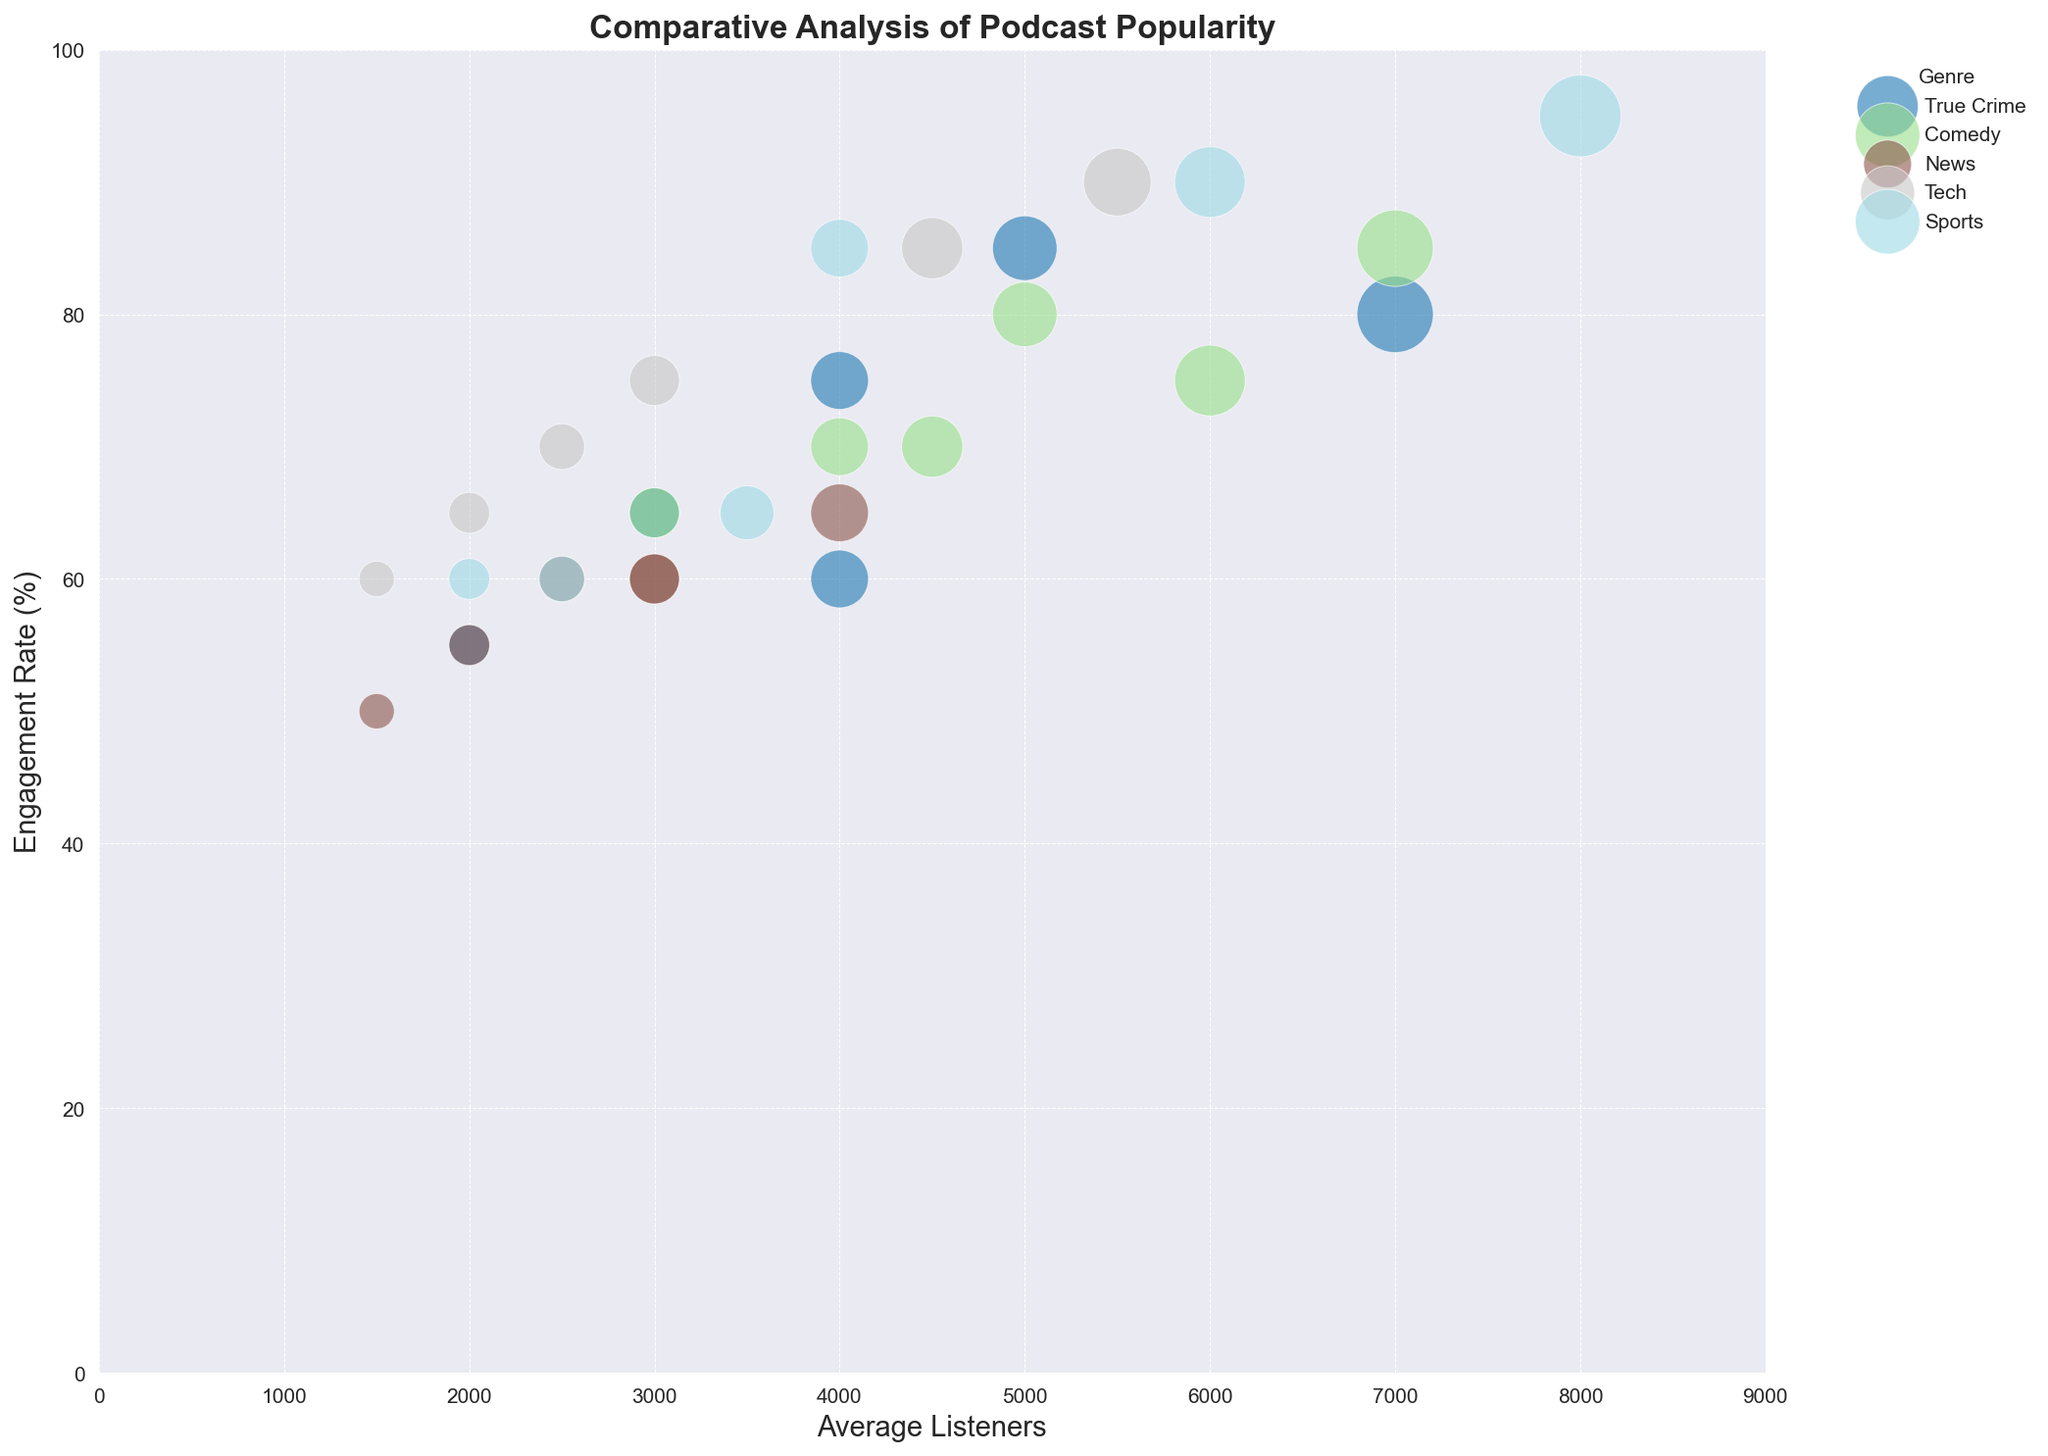What genre has the highest overall engagement rate and which age and gender group does it represent? To find the highest overall engagement rate, we need to look at the bubbles with the highest position on the y-axis (Engagement Rate). The highest bubble corresponds to the Sports genre for the 25-34 male listener group. This is indicated by the label and the highest position on the y-axis.
Answer: Sports, 25-34, Male What's the average engagement rate for True Crime podcasts across all demographic segments? To calculate the average engagement rate for True Crime, we sum the engagement rates of all True Crime segments and divide by the number of segments. The engagement rates are 85, 80, 75, 65, 60, and 55. So, (85+80+75+65+60+55)/6 = 70.
Answer: 70 Which genre has the most balanced average listener between males and females aged 25-34? To determine this, compare the average listeners for males and females in the 25-34 age group for each genre. For True Crime: Female 7000, Male 4000; Comedy: Female 6000, Male 7000; News: Female 4000, Male 3000; Tech: Female 2500, Male 5500; Sports: Female 3500, Male 8000. The smallest difference is in Comedy.
Answer: Comedy For Tech podcasts, what is the total number of average listeners in the 35-44 age group? Summing up the average listeners for males and females in the 35-44 age group for Tech podcasts: Female 1500, Male 3000. So, 1500 + 3000 = 4500.
Answer: 4500 In which age group does the Comedy genre have the highest engagement rate? To find this, look at the y-axis positions of the bubbles for Comedy for each age group and compare them. The highest engagement rate for Comedy is in the 25-34 male group at 85%.
Answer: 25-34, Male How does the engagement rate of News podcasts compare between the 25-34 female and the 25-34 male demographic? The engagement rate for News podcasts for 25-34 female is 65% and for 25-34 male is 60%. Thus, the engagement rate for females is slightly higher.
Answer: Female is higher Which genre contains the largest bubble and what does it represent? The largest bubble corresponds to the highest average listeners. This bubble is in the Sports genre for the 25-34 male demographic representing 8000 average listeners.
Answer: Sports, 25-34, Male What's the difference in engagement rate between the Tech and Comedy genres for the 18-24 male listener demographic? The engagement rates for Tech and Comedy in the 18-24 male listener group are 85% and 80%, respectively. The difference is 85 - 80 = 5%.
Answer: 5% 